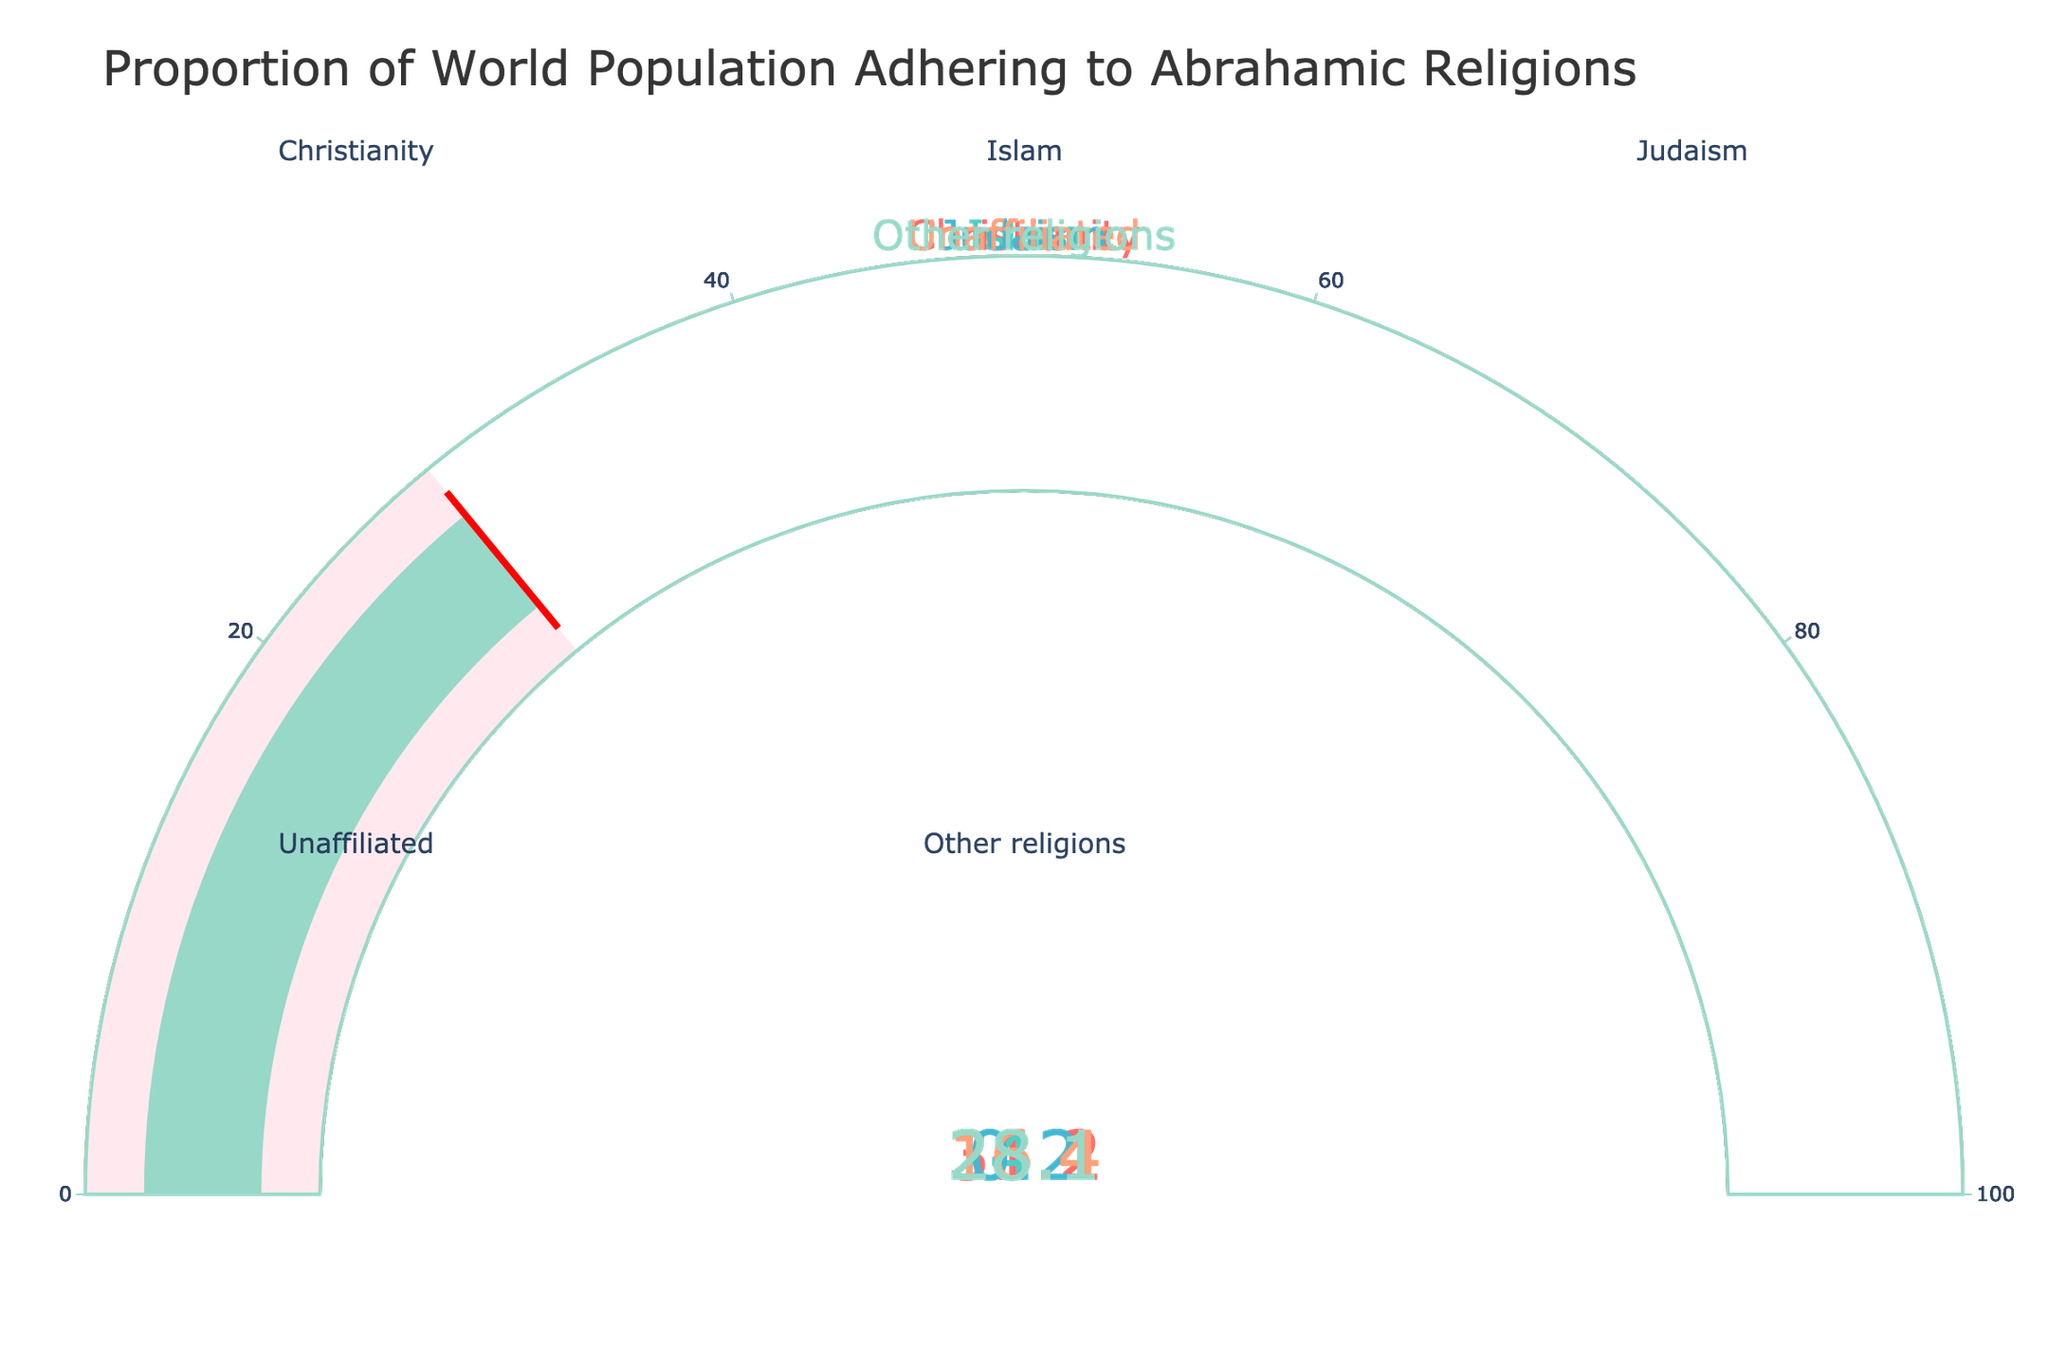Which religion has the highest proportion in the world population according to the chart? By analyzing the gauge chart, identify the religion with the highest value on the gauge. Christianity has the highest proportion with 31.2%.
Answer: Christianity Which religion has the lowest proportion in the world population according to the chart? By analyzing the gauge chart, identify the religion with the lowest value on the gauge. Judaism has the lowest proportion with 0.2%.
Answer: Judaism What is the combined proportion of the world population adhering to Christianity and Islam? Add the percentage values of Christianity and Islam: 31.2% + 24.1% = 55.3%.
Answer: 55.3% How does the proportion of unaffiliated individuals compare to that of other religions? Compare the gauge values of unaffiliated individuals (16.4%) and other religions (28.1%). Unaffiliated individuals have a lower proportion compared to other religions.
Answer: Other religions have a higher proportion What is the total proportion of the world population that follows Abrahamic religions (Christianity, Islam, Judaism)? Sum the percentages of Christianity, Islam, and Judaism: 31.2% + 24.1% + 0.2% = 55.5%.
Answer: 55.5% How much larger is the percentage of Christianity compared to Judaism? Subtract the percentage of Judaism from the percentage of Christianity: 31.2% - 0.2% = 31%.
Answer: 31% Which two religions together exceed the proportion of the unaffiliated category? Identify pairs of religions whose combined percentages exceed the unaffiliated value (16.4%). Both Christianity (31.2%) and Islam (24.1%) alone exceed unaffiliated, so any two religions chosen will also exceed.
Answer: Any two religions What is the average proportion of the world population adhering to all listed religions including unaffiliated? Find the average by summing the percentages of all categories and dividing by the number of categories: (31.2% + 24.1% + 0.2% + 16.4% + 28.1%) / 5 = 20%.
Answer: 20% What proportion of the world population does not adhere to any of the Abrahamic religions? Subtract the combined proportion of Abrahamic religion followers from 100%: 100% - 55.5% = 44.5%.
Answer: 44.5% 